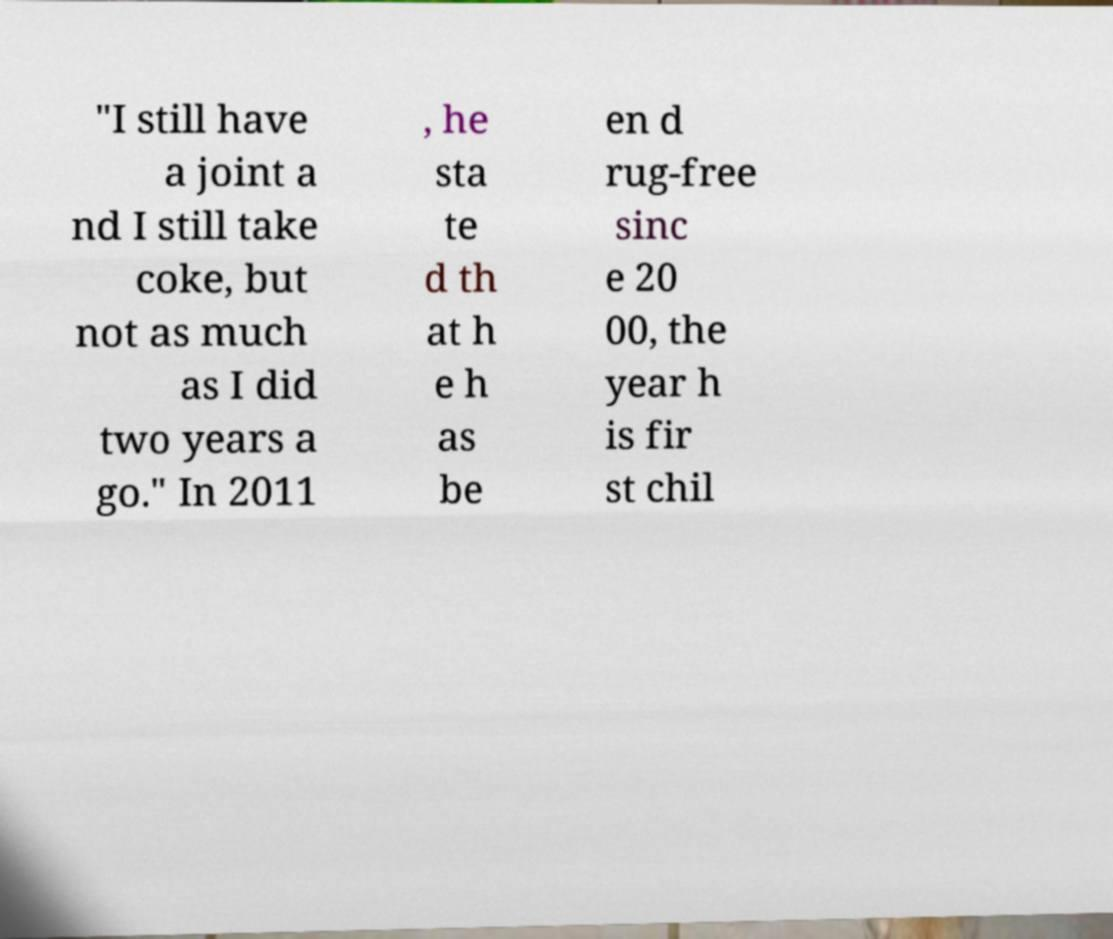For documentation purposes, I need the text within this image transcribed. Could you provide that? "I still have a joint a nd I still take coke, but not as much as I did two years a go." In 2011 , he sta te d th at h e h as be en d rug-free sinc e 20 00, the year h is fir st chil 